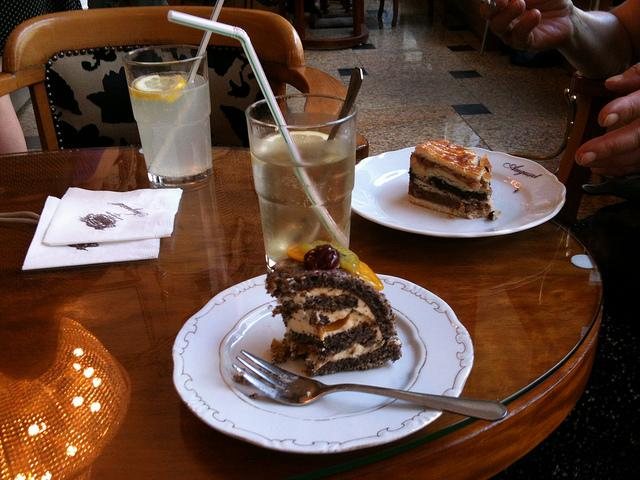How do you say the name of the item on the plate next to the cake in Italian? forchetta 